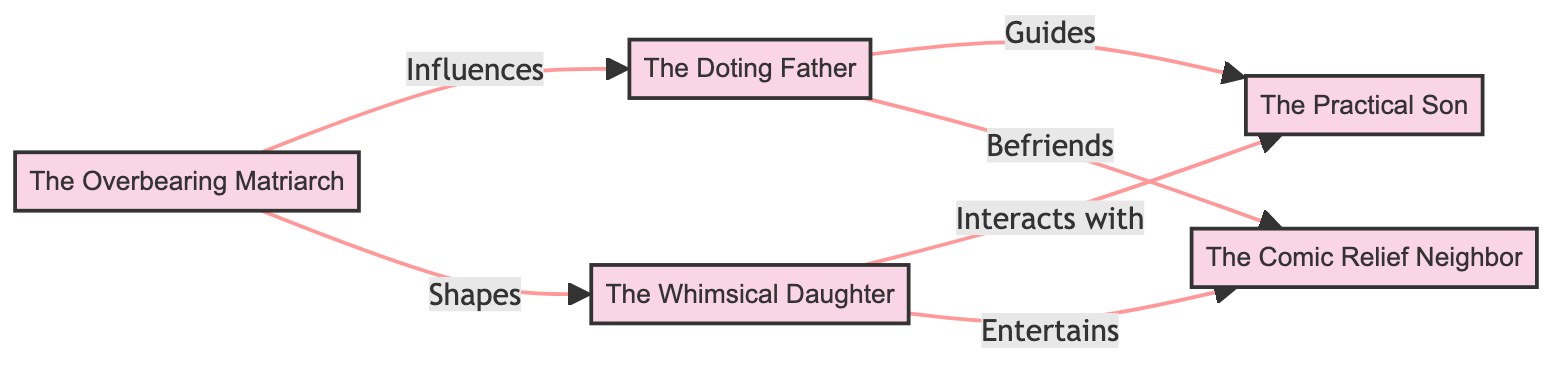What is the label of node 3? Node 3 is labeled "The Whimsical Daughter" as indicated in the diagram.
Answer: The Whimsical Daughter How many nodes are in the diagram? The diagram contains 5 nodes: The Overbearing Matriarch, The Doting Father, The Whimsical Daughter, The Practical Son, and The Comic Relief Neighbor.
Answer: 5 What type of relationship exists between The Overbearing Matriarch and The Doting Father? The Overbearing Matriarch influences The Doting Father, as shown by the directed edge from node 1 to node 2 labeled "Influences."
Answer: Influences Which node interacts with The Practical Son? The Whimsical Daughter interacts with The Practical Son based on the directed edge from node 3 to node 4 labeled "Interacts with."
Answer: The Whimsical Daughter How many directed edges are in the diagram? The diagram contains 6 directed edges that illustrate relationships between the nodes.
Answer: 6 What relationships does The Whimsical Daughter have with other nodes? The Whimsical Daughter interacts with The Practical Son and entertains The Comic Relief Neighbor, as shown by the edges going from node 3 to nodes 4 and 5.
Answer: Interacts with The Practical Son, entertains The Comic Relief Neighbor Which character archetype befriends The Comic Relief Neighbor? The Doting Father befriends The Comic Relief Neighbor according to the directed edge from node 2 to node 5 labeled "Befriends."
Answer: The Doting Father Who is guided by The Doting Father? The Practical Son is guided by The Doting Father, as indicated by the directed edge from node 2 to node 4 labeled "Guides."
Answer: The Practical Son What is the edge relationship between The Overbearing Matriarch and The Whimsical Daughter? The edge from node 1 to node 3 signifies that The Overbearing Matriarch shapes The Whimsical Daughter, as described by the label "Shapes."
Answer: Shapes 